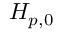<formula> <loc_0><loc_0><loc_500><loc_500>H _ { p , 0 }</formula> 